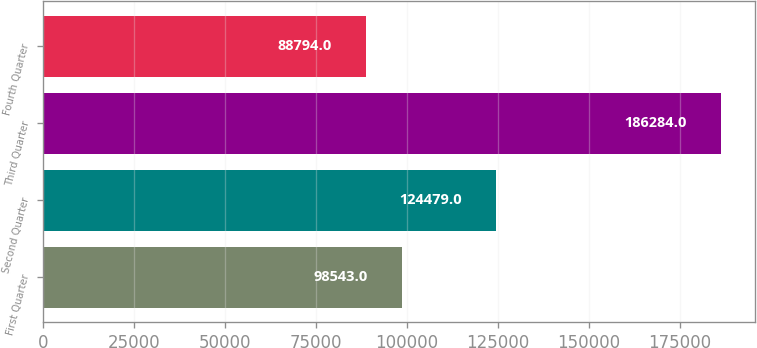Convert chart. <chart><loc_0><loc_0><loc_500><loc_500><bar_chart><fcel>First Quarter<fcel>Second Quarter<fcel>Third Quarter<fcel>Fourth Quarter<nl><fcel>98543<fcel>124479<fcel>186284<fcel>88794<nl></chart> 